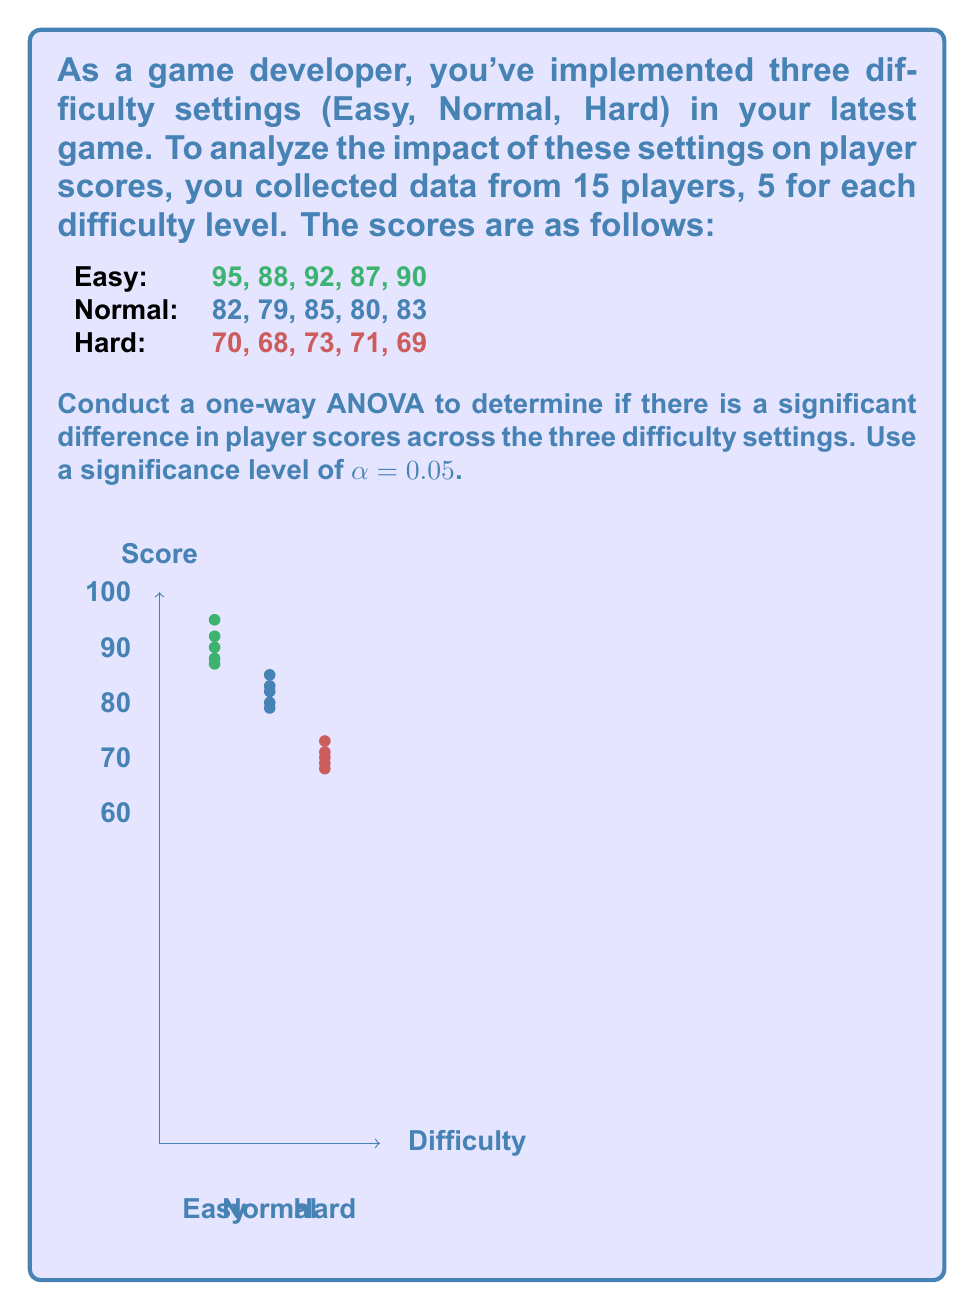Can you solve this math problem? Let's follow the steps to conduct a one-way ANOVA:

1) Calculate the sum of squares:

   a) Total sum of squares (SST):
      $$SST = \sum_{i=1}^{n} (x_i - \bar{x})^2$$
      where $x_i$ are all scores and $\bar{x}$ is the grand mean.
      
   b) Between-group sum of squares (SSB):
      $$SSB = \sum_{j=1}^{k} n_j(\bar{x}_j - \bar{x})^2$$
      where $k$ is the number of groups, $n_j$ is the size of each group, and $\bar{x}_j$ is the mean of each group.
      
   c) Within-group sum of squares (SSW):
      $$SSW = SST - SSB$$

2) Calculate degrees of freedom:
   - Total df: $n - 1 = 15 - 1 = 14$
   - Between-group df: $k - 1 = 3 - 1 = 2$
   - Within-group df: $n - k = 15 - 3 = 12$

3) Calculate mean squares:
   $$MSB = \frac{SSB}{df_B}, MSW = \frac{SSW}{df_W}$$

4) Calculate F-statistic:
   $$F = \frac{MSB}{MSW}$$

5) Find critical F-value:
   $F_{crit} = F_{0.05, 2, 12}$ (from F-distribution table)

6) Make decision:
   If $F > F_{crit}$, reject null hypothesis.

Calculations:

Grand mean: $\bar{x} = 80.8$

Group means: 
$\bar{x}_{Easy} = 90.4$
$\bar{x}_{Normal} = 81.8$
$\bar{x}_{Hard} = 70.2$

SST = 1644.93
SSB = 1520.13
SSW = 124.8

MSB = 760.065
MSW = 10.4

F = 73.08

$F_{crit} = 3.89$ (from F-distribution table)

Since $73.08 > 3.89$, we reject the null hypothesis.
Answer: F(2,12) = 73.08, p < 0.05. Significant difference in scores across difficulty levels. 